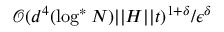Convert formula to latex. <formula><loc_0><loc_0><loc_500><loc_500>\mathcal { O } ( d ^ { 4 } ( \log ^ { * } N ) | | H | | t ) ^ { 1 + \delta } / \epsilon ^ { \delta }</formula> 